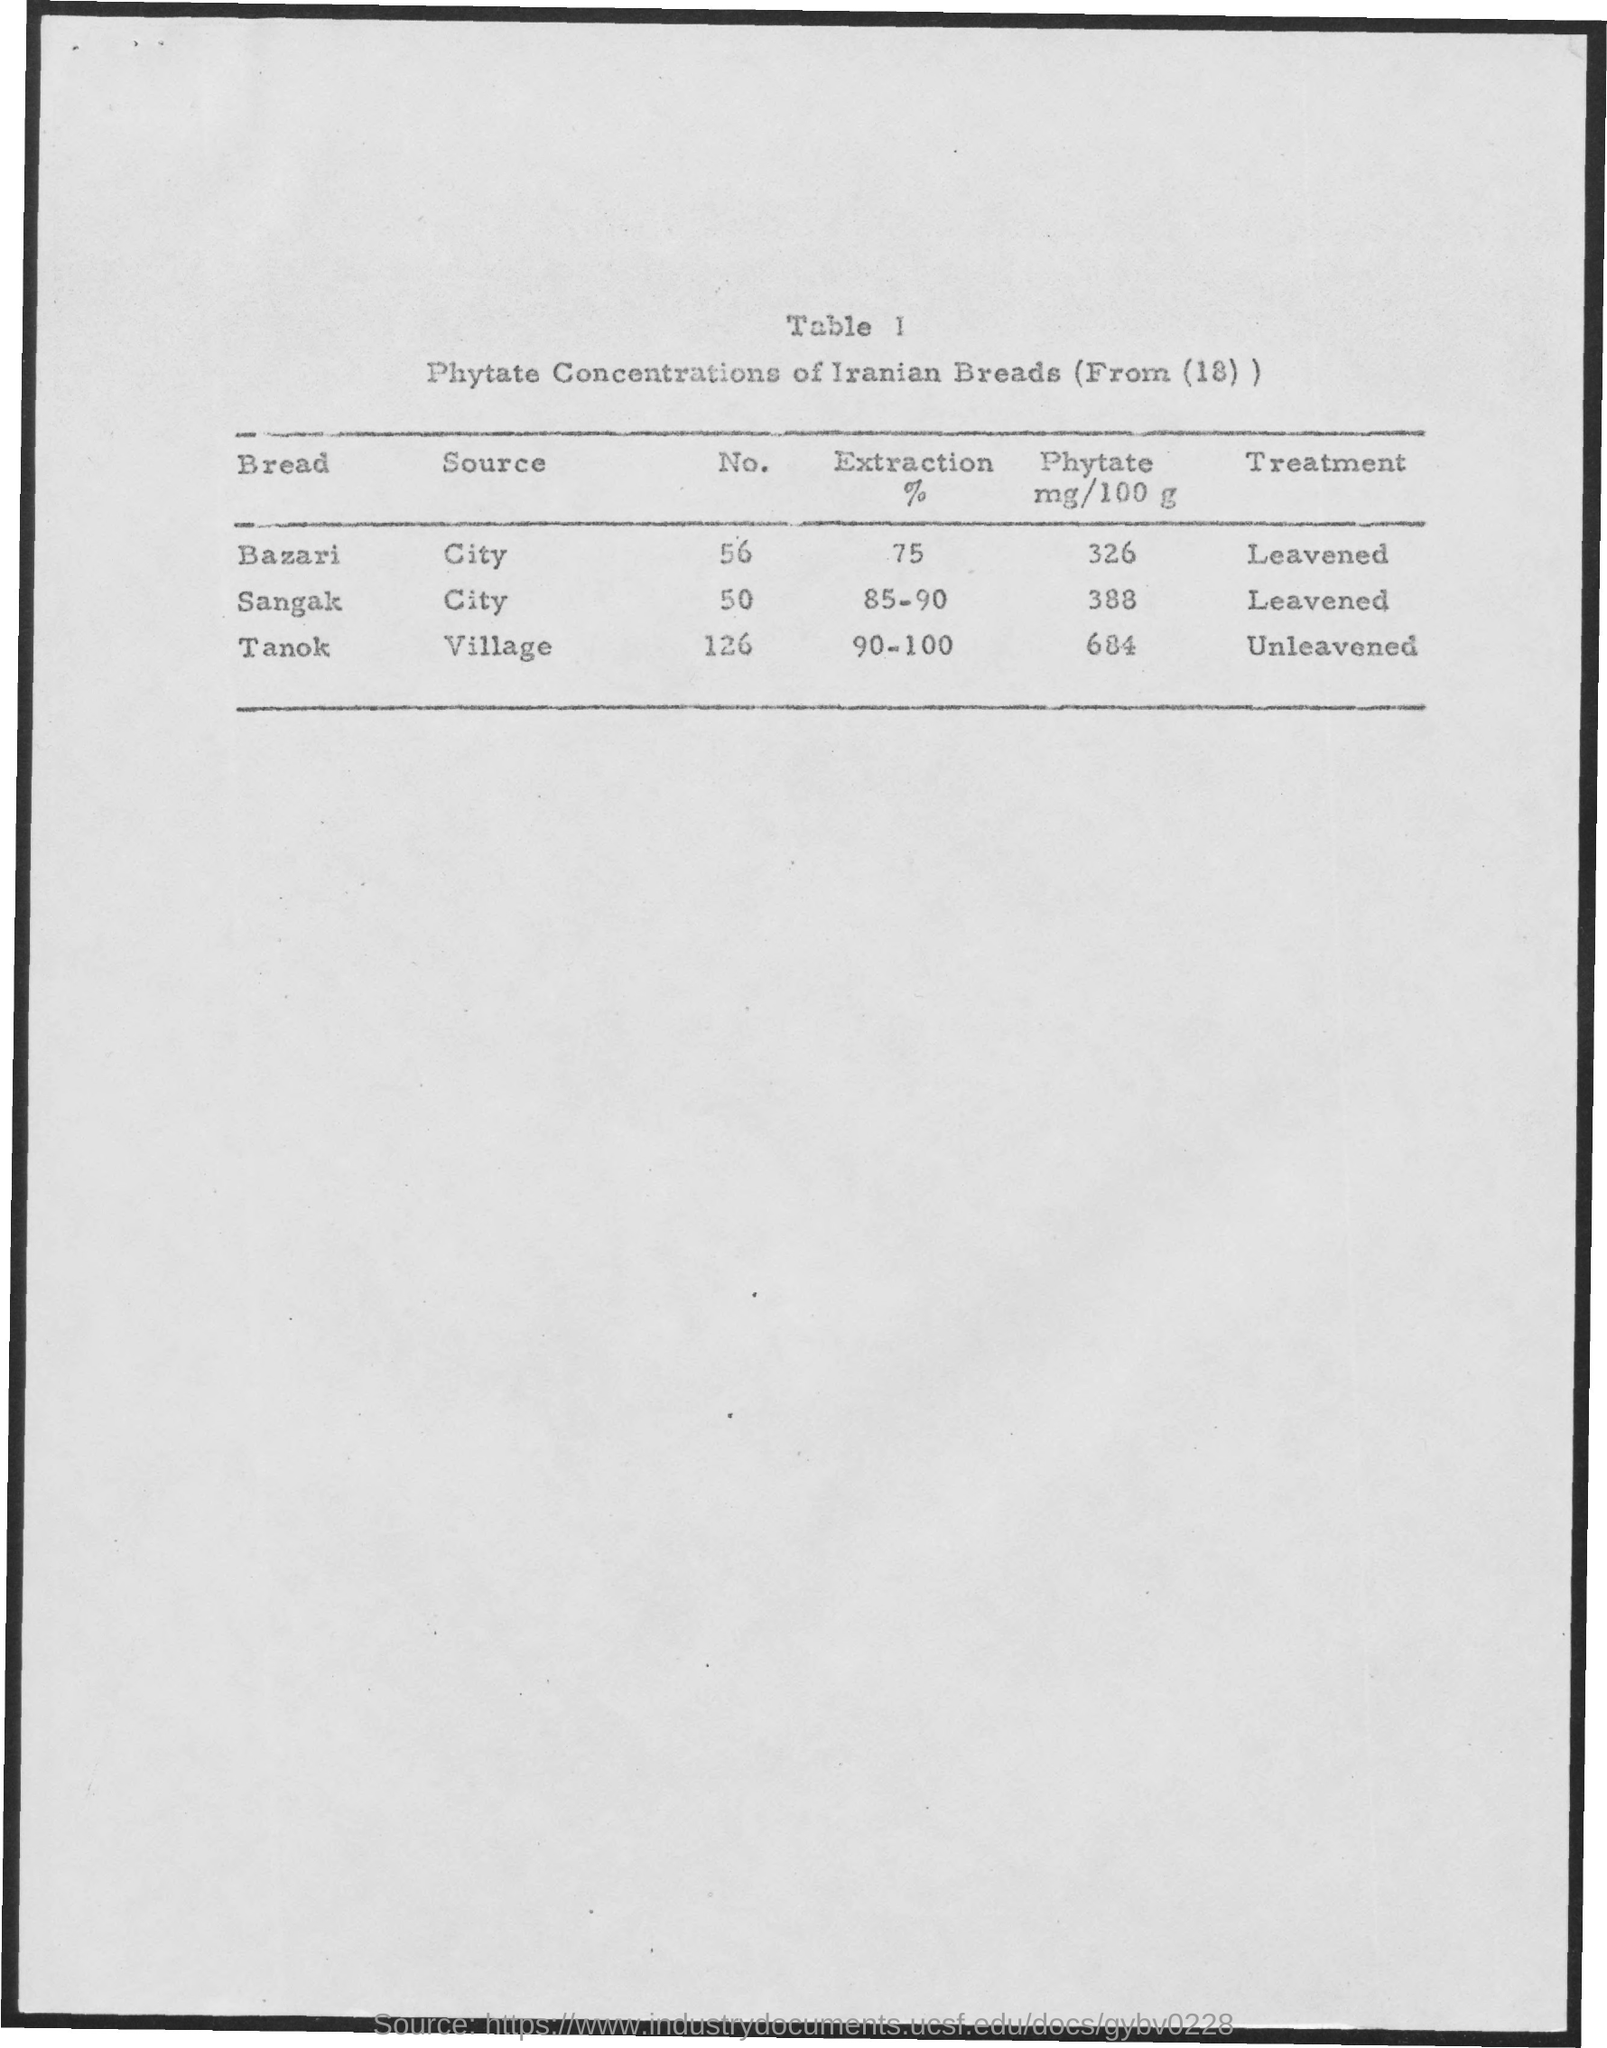What is the table no. mentioned in the given page ?
Offer a terse response. 1. What is the treatment for tanok ?
Ensure brevity in your answer.  Unleavened. What is the treatment for sangak
Give a very brief answer. Leavened. What is the source of tanok
Offer a terse response. Village. 